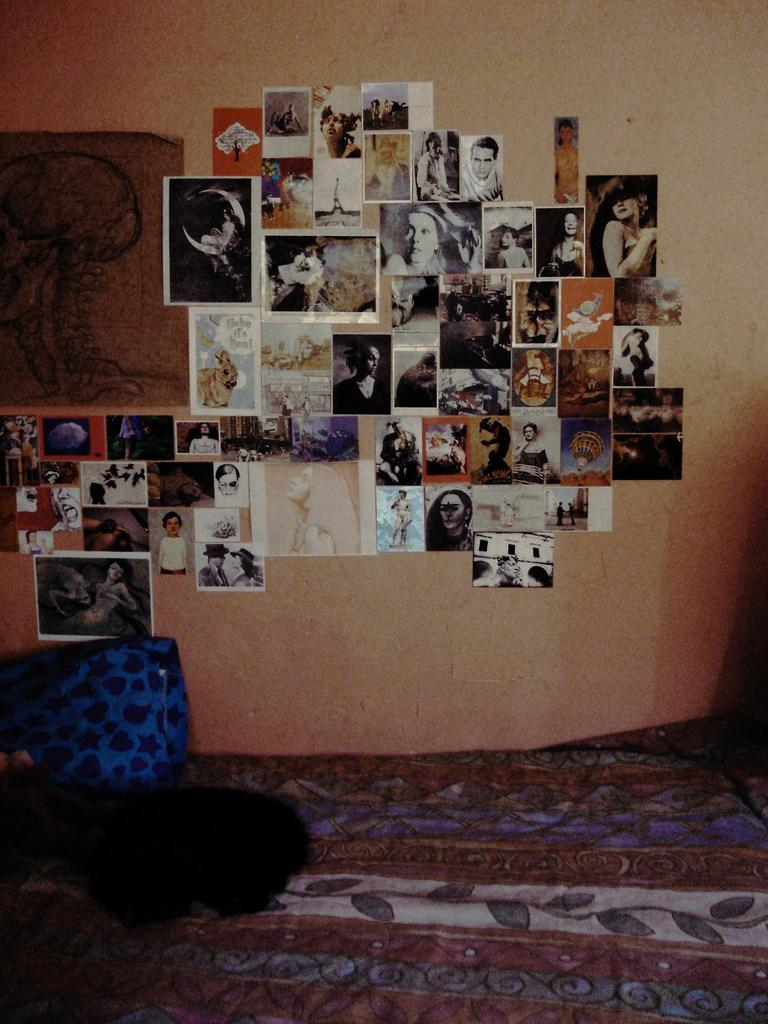What is on the wall in the image? There is a wall with photographs and a poster in the image. What is at the bottom of the image? There is a cloth at the bottom of the image. What is placed on the cloth? There is a pillow on the cloth in the image. What type of plough can be seen in the image? There is no plough present in the image. How does the sleet affect the poster on the wall in the image? There is no sleet present in the image, so it cannot affect the poster. 